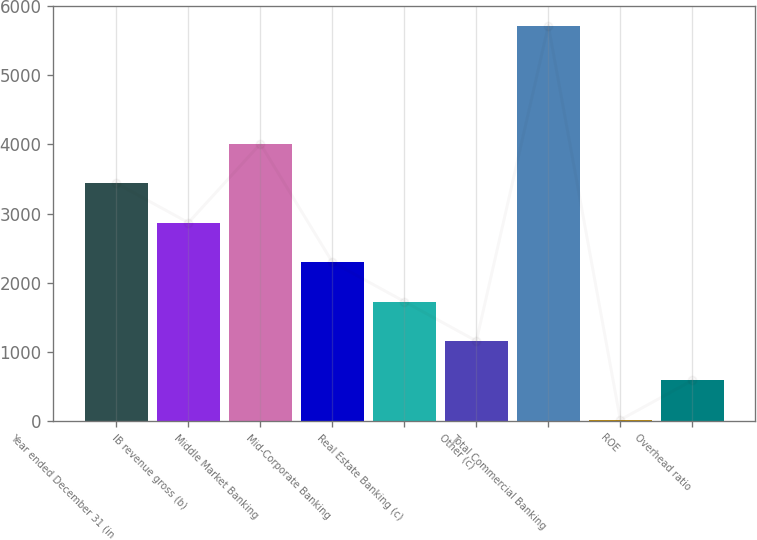<chart> <loc_0><loc_0><loc_500><loc_500><bar_chart><fcel>Year ended December 31 (in<fcel>IB revenue gross (b)<fcel>Middle Market Banking<fcel>Mid-Corporate Banking<fcel>Real Estate Banking (c)<fcel>Other (c)<fcel>Total Commercial Banking<fcel>ROE<fcel>Overhead ratio<nl><fcel>3438.4<fcel>2868<fcel>4008.8<fcel>2297.6<fcel>1727.2<fcel>1156.8<fcel>5720<fcel>16<fcel>586.4<nl></chart> 